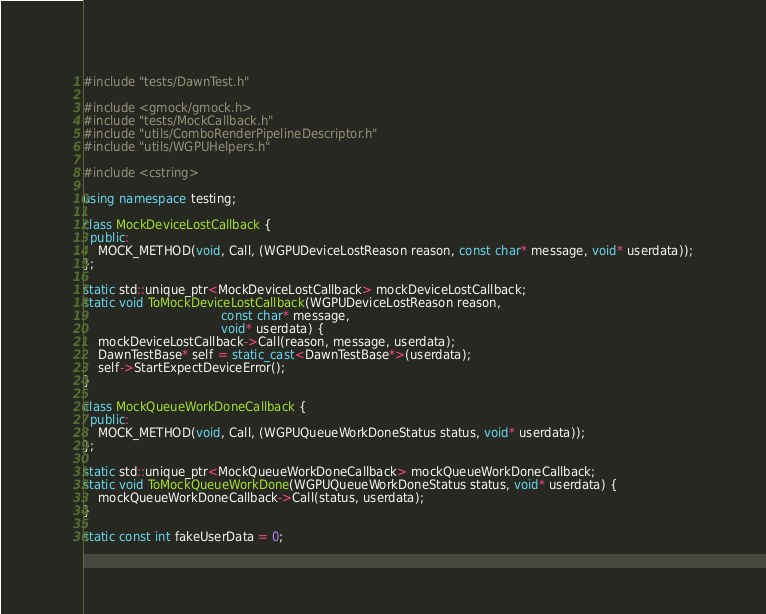Convert code to text. <code><loc_0><loc_0><loc_500><loc_500><_C++_>
#include "tests/DawnTest.h"

#include <gmock/gmock.h>
#include "tests/MockCallback.h"
#include "utils/ComboRenderPipelineDescriptor.h"
#include "utils/WGPUHelpers.h"

#include <cstring>

using namespace testing;

class MockDeviceLostCallback {
  public:
    MOCK_METHOD(void, Call, (WGPUDeviceLostReason reason, const char* message, void* userdata));
};

static std::unique_ptr<MockDeviceLostCallback> mockDeviceLostCallback;
static void ToMockDeviceLostCallback(WGPUDeviceLostReason reason,
                                     const char* message,
                                     void* userdata) {
    mockDeviceLostCallback->Call(reason, message, userdata);
    DawnTestBase* self = static_cast<DawnTestBase*>(userdata);
    self->StartExpectDeviceError();
}

class MockQueueWorkDoneCallback {
  public:
    MOCK_METHOD(void, Call, (WGPUQueueWorkDoneStatus status, void* userdata));
};

static std::unique_ptr<MockQueueWorkDoneCallback> mockQueueWorkDoneCallback;
static void ToMockQueueWorkDone(WGPUQueueWorkDoneStatus status, void* userdata) {
    mockQueueWorkDoneCallback->Call(status, userdata);
}

static const int fakeUserData = 0;
</code> 